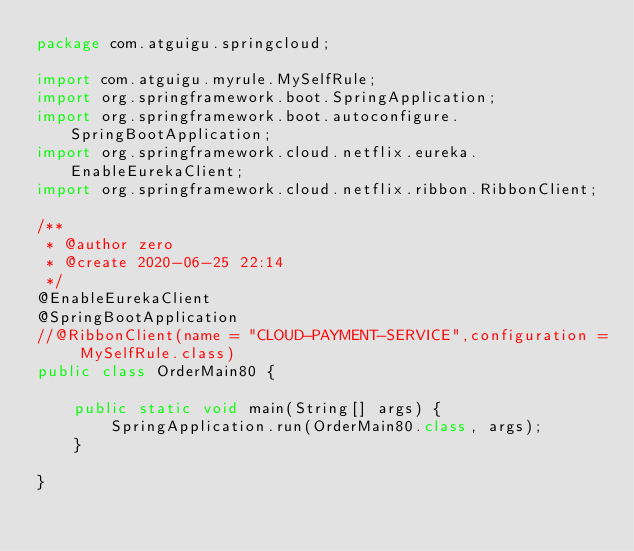Convert code to text. <code><loc_0><loc_0><loc_500><loc_500><_Java_>package com.atguigu.springcloud;

import com.atguigu.myrule.MySelfRule;
import org.springframework.boot.SpringApplication;
import org.springframework.boot.autoconfigure.SpringBootApplication;
import org.springframework.cloud.netflix.eureka.EnableEurekaClient;
import org.springframework.cloud.netflix.ribbon.RibbonClient;

/**
 * @author zero
 * @create 2020-06-25 22:14
 */
@EnableEurekaClient
@SpringBootApplication
//@RibbonClient(name = "CLOUD-PAYMENT-SERVICE",configuration = MySelfRule.class)
public class OrderMain80 {

    public static void main(String[] args) {
        SpringApplication.run(OrderMain80.class, args);
    }

}
</code> 